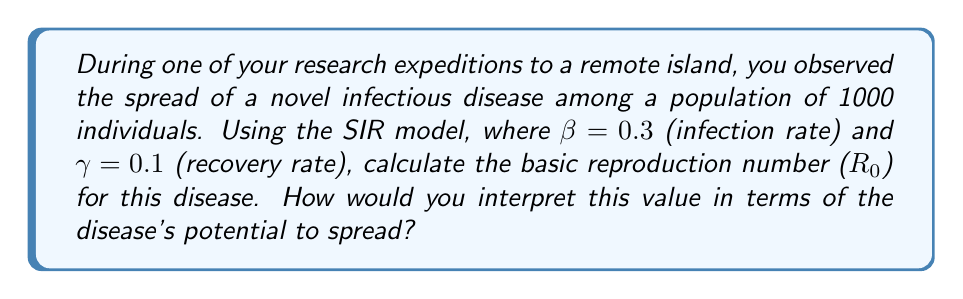Teach me how to tackle this problem. To solve this problem, we'll follow these steps:

1. Recall the SIR model equations:
   $$\frac{dS}{dt} = -\beta SI$$
   $$\frac{dI}{dt} = \beta SI - \gamma I$$
   $$\frac{dR}{dt} = \gamma I$$

2. The basic reproduction number ($R_0$) is defined as the average number of secondary infections caused by one infected individual in a completely susceptible population. In the SIR model, it's calculated as:

   $$R_0 = \frac{\beta}{\gamma}$$

3. Given:
   $\beta = 0.3$ (infection rate)
   $\gamma = 0.1$ (recovery rate)

4. Substitute these values into the formula:
   $$R_0 = \frac{0.3}{0.1} = 3$$

5. Interpretation:
   - If $R_0 > 1$, the disease will spread and potentially cause an epidemic.
   - If $R_0 < 1$, the disease will die out.
   - In this case, $R_0 = 3 > 1$, indicating that the disease has the potential to spread rapidly.

6. More specifically, $R_0 = 3$ means that, on average, each infected individual will infect 3 other individuals during their infectious period, assuming a fully susceptible population.

This high $R_0$ value suggests that the disease has a significant potential to spread and could lead to a substantial outbreak if left unchecked. As a biologist, you would likely recommend immediate intervention measures to control the spread of the disease on the island.
Answer: $R_0 = 3$; The disease has high potential to spread, with each infected individual likely to infect 3 others in a fully susceptible population. 